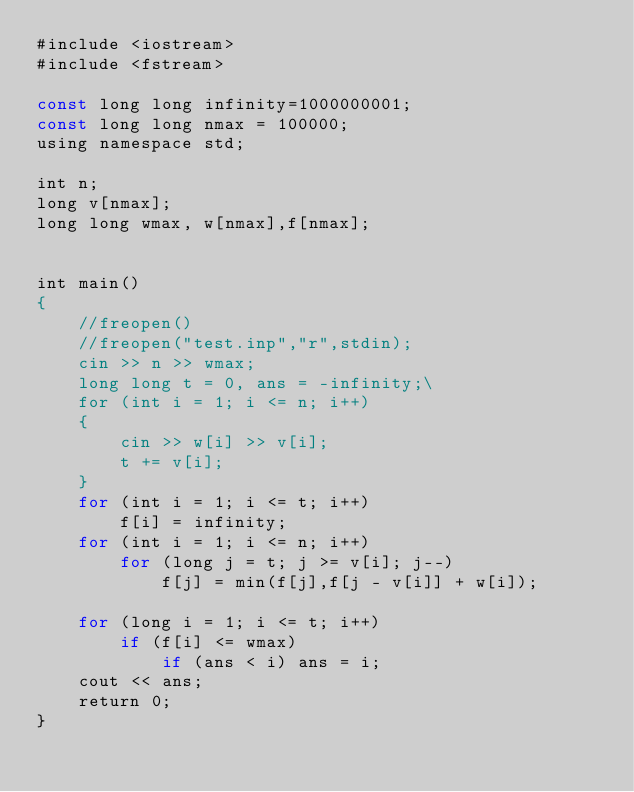Convert code to text. <code><loc_0><loc_0><loc_500><loc_500><_Pascal_>#include <iostream>
#include <fstream>

const long long infinity=1000000001;
const long long nmax = 100000;
using namespace std;

int n;
long v[nmax];
long long wmax, w[nmax],f[nmax];


int main()
{
    //freopen()
    //freopen("test.inp","r",stdin);
    cin >> n >> wmax;
    long long t = 0, ans = -infinity;\
    for (int i = 1; i <= n; i++)
    {
        cin >> w[i] >> v[i];
        t += v[i];
    }
    for (int i = 1; i <= t; i++)
        f[i] = infinity;
    for (int i = 1; i <= n; i++)
        for (long j = t; j >= v[i]; j--)
            f[j] = min(f[j],f[j - v[i]] + w[i]);

    for (long i = 1; i <= t; i++)
        if (f[i] <= wmax)
            if (ans < i) ans = i;
    cout << ans;
    return 0;
}
</code> 